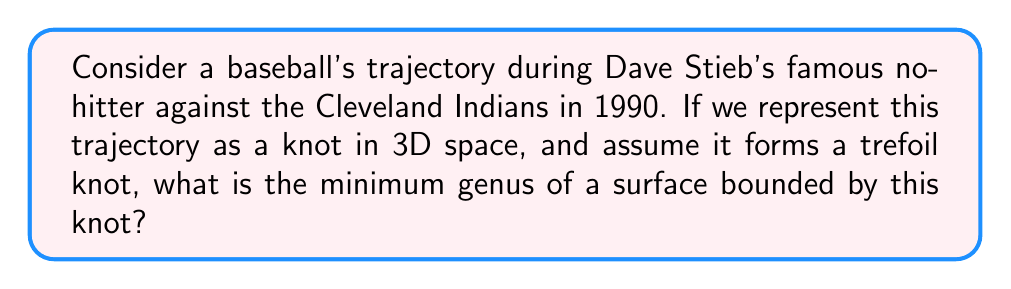Help me with this question. To solve this problem, we'll follow these steps:

1) First, recall that the genus of a surface is the number of "holes" or "handles" it has. For a surface bounded by a knot, the genus is always greater than or equal to zero.

2) The trefoil knot is one of the simplest non-trivial knots. It's known that the minimum genus of a surface bounded by a trefoil knot is 1.

3) This can be proven using the Seifert algorithm:

   a) Create a Seifert surface for the trefoil knot.
   b) The Euler characteristic $\chi$ of this surface is related to its genus $g$ by the formula:
      $$\chi = 2 - 2g - b$$
      where $b$ is the number of boundary components (in this case, $b=1$ for the single knot).

   c) For a trefoil knot, the Seifert surface has Euler characteristic $\chi = -1$.

   d) Substituting these values:
      $$-1 = 2 - 2g - 1$$
      $$-1 = 1 - 2g$$
      $$2g = 2$$
      $$g = 1$$

4) Therefore, the minimum genus of a surface bounded by a trefoil knot is 1.

5) In the context of Dave Stieb's no-hitter, this means that if we model the baseball's trajectory as a trefoil knot, the simplest surface that could be bounded by this trajectory would have one "hole" or "handle".
Answer: 1 